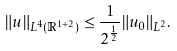<formula> <loc_0><loc_0><loc_500><loc_500>\| u \| _ { L ^ { 4 } ( \mathbb { R } ^ { 1 + 2 } ) } \leq \frac { 1 } { 2 ^ { \frac { 1 } { 2 } } } \| u _ { 0 } \| _ { L ^ { 2 } } .</formula> 